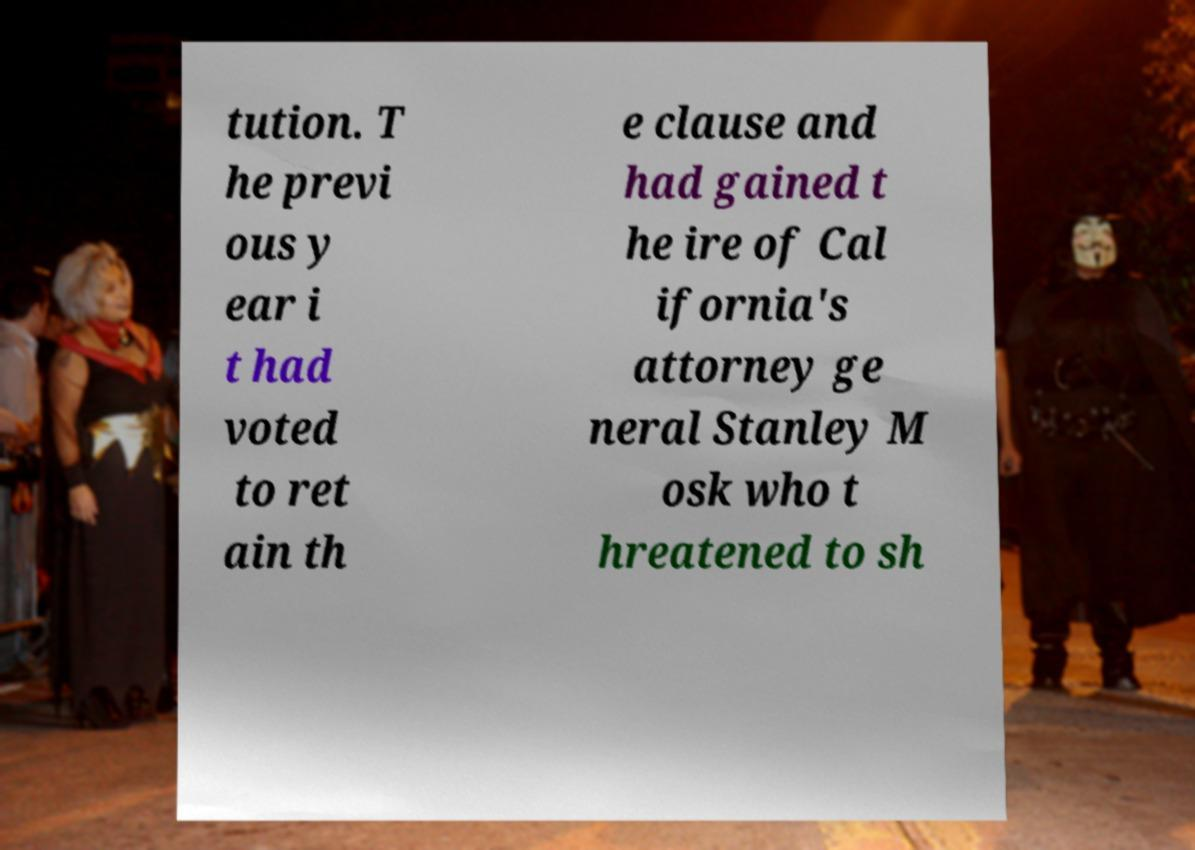Could you extract and type out the text from this image? tution. T he previ ous y ear i t had voted to ret ain th e clause and had gained t he ire of Cal ifornia's attorney ge neral Stanley M osk who t hreatened to sh 